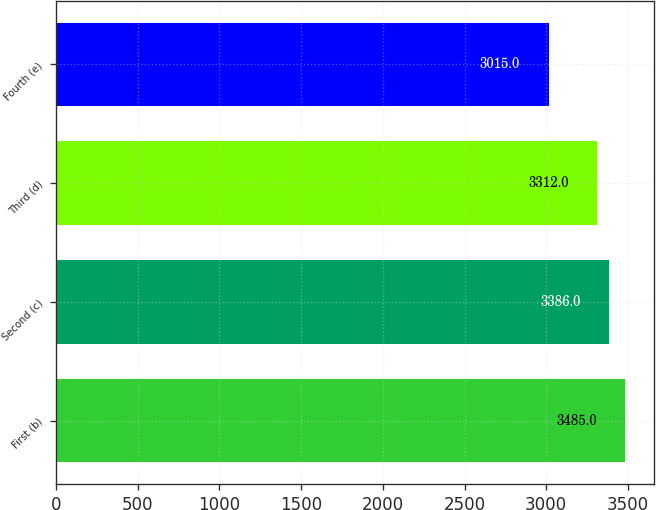<chart> <loc_0><loc_0><loc_500><loc_500><bar_chart><fcel>First (b)<fcel>Second (c)<fcel>Third (d)<fcel>Fourth (e)<nl><fcel>3485<fcel>3386<fcel>3312<fcel>3015<nl></chart> 